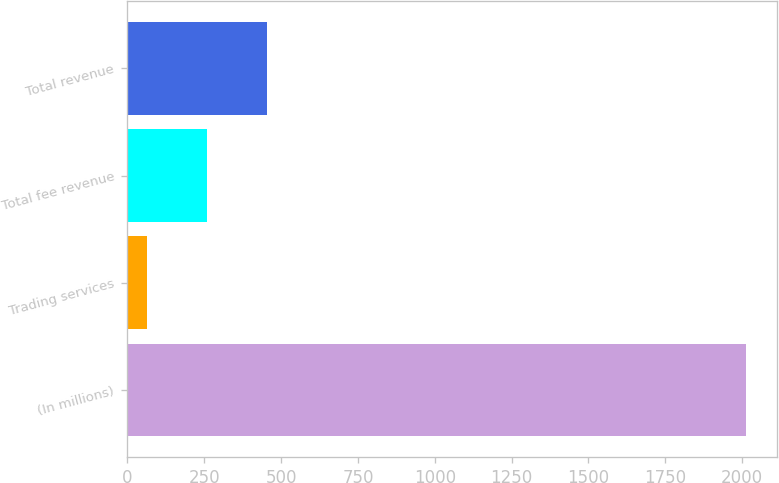Convert chart to OTSL. <chart><loc_0><loc_0><loc_500><loc_500><bar_chart><fcel>(In millions)<fcel>Trading services<fcel>Total fee revenue<fcel>Total revenue<nl><fcel>2013<fcel>63<fcel>258<fcel>453<nl></chart> 